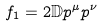Convert formula to latex. <formula><loc_0><loc_0><loc_500><loc_500>f _ { 1 } = 2 \mathbb { D } p ^ { \mu } p ^ { \nu }</formula> 